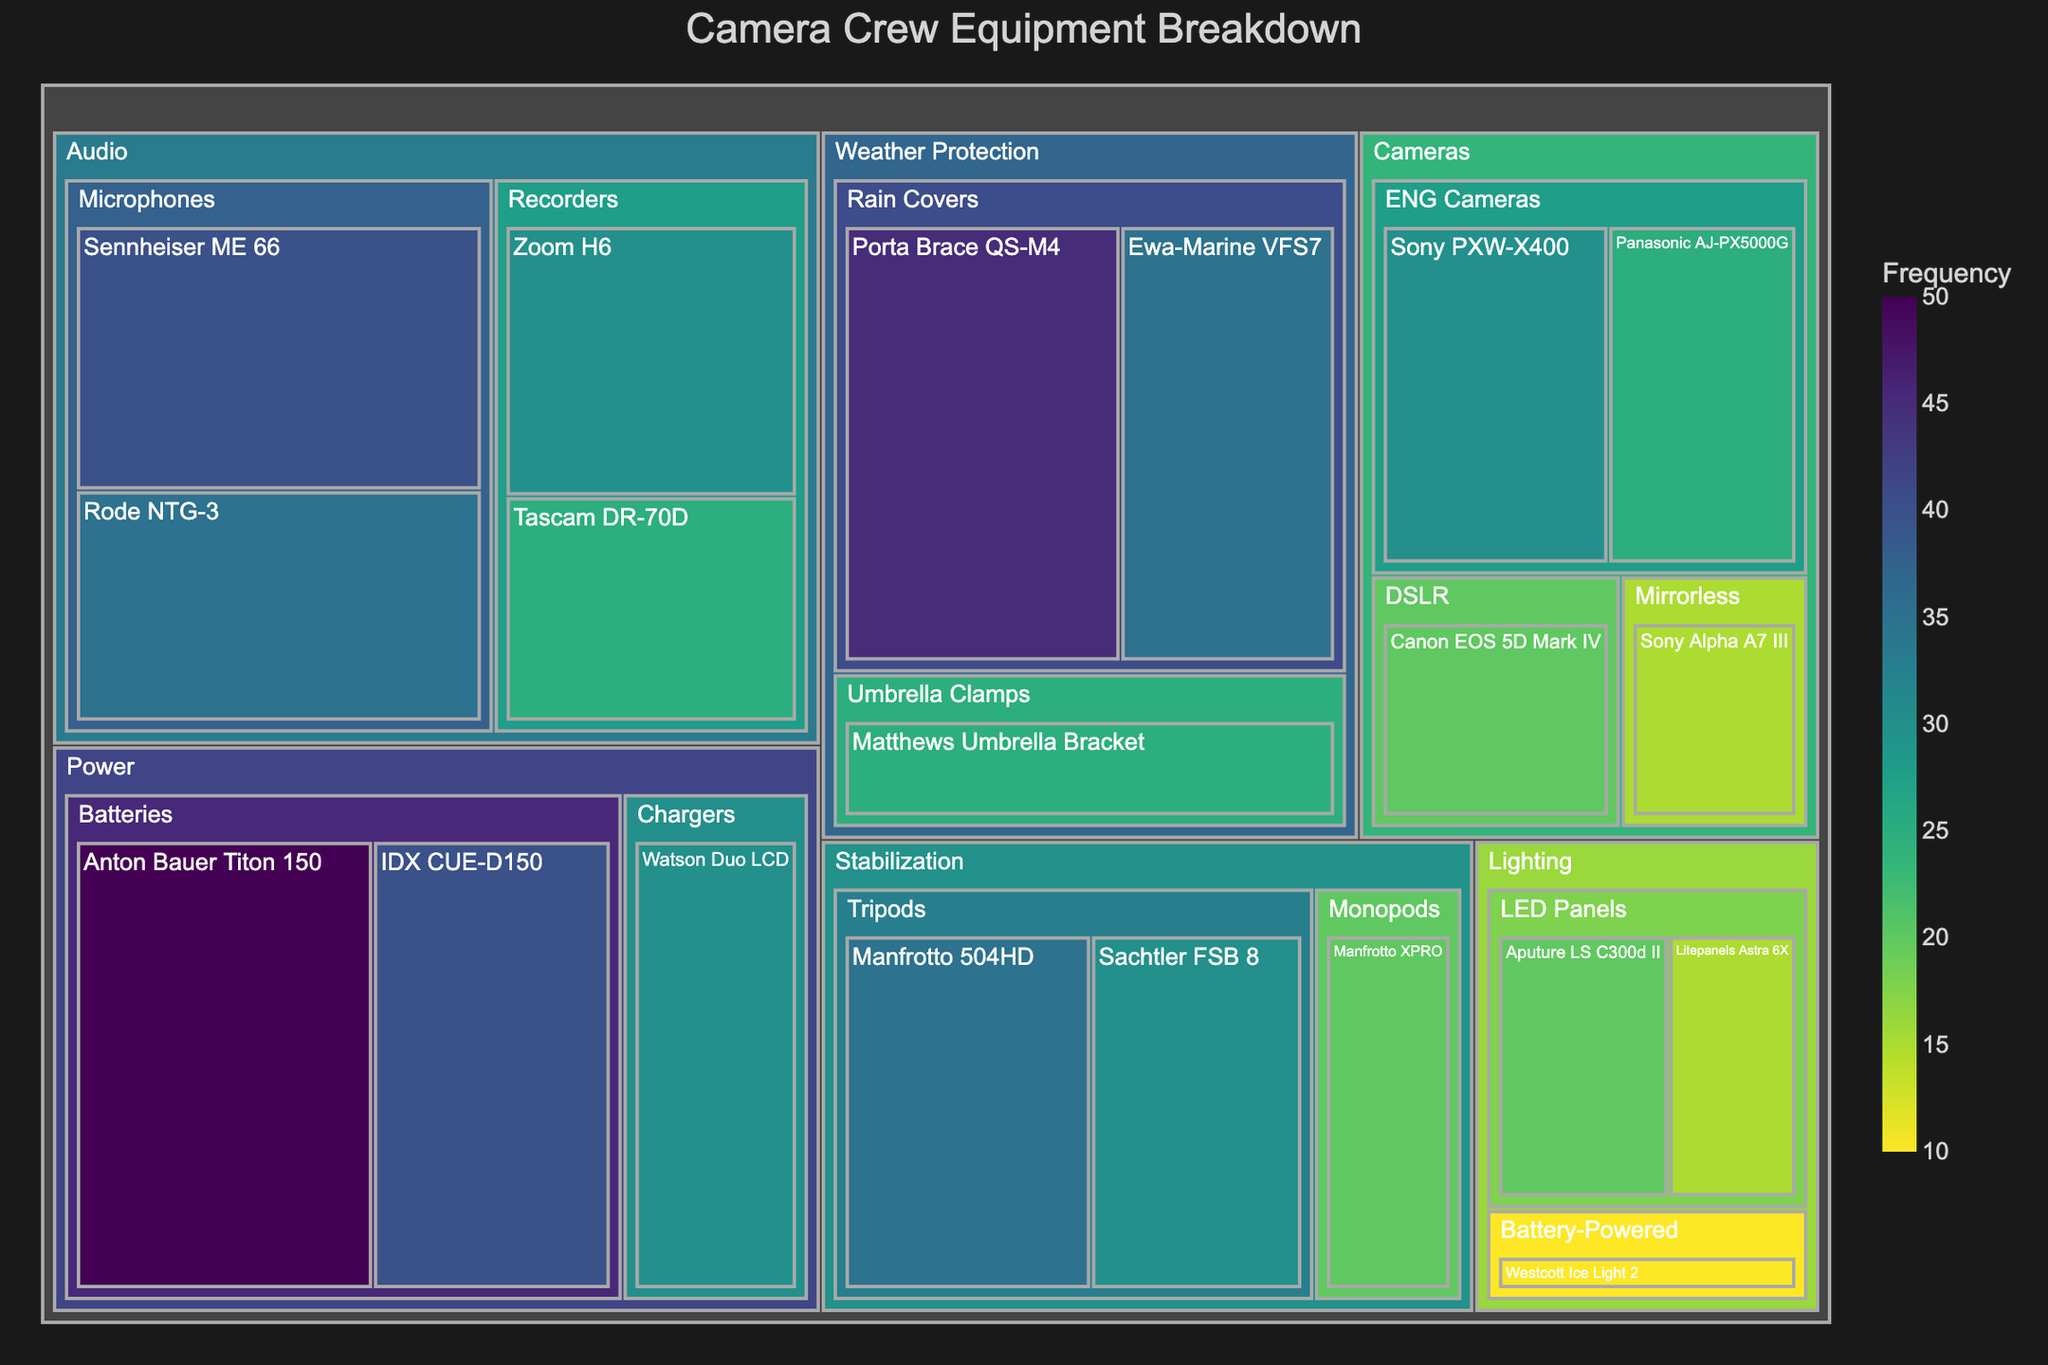Which equipment has the highest frequency in the 'Power' category? Find the 'Power' category and identify the equipment with the highest frequency. Anton Bauer Titon 150 has a frequency of 50, which is the highest in the 'Power' category.
Answer: Anton Bauer Titon 150 What is the total frequency of all equipment in the 'Stabilization' category? Identify all subcategories under 'Stabilization' and add their frequencies. Manfrotto 504HD (35) + Sachtler FSB 8 (30) + Manfrotto XPRO (20) = 35 + 30 + 20 = 85.
Answer: 85 Which subcategory has the lowest total frequency in the 'Lighting' category? Calculate the total frequency for each subcategory in 'Lighting' and compare them. LED Panels (20 + 15 = 35), Battery-Powered (10). Battery-Powered has the lowest total frequency of 10.
Answer: Battery-Powered How many pieces of equipment have a frequency above 30? Count all pieces of equipment with a frequency greater than 30. There are 7 pieces of equipment (Sony PXW-X400, Panasonic AJ-PX5000G, Sennheiser ME 66, Rode NTG-3, Porta Brace QS-M4, Anton Bauer Titon 150, IDX CUE-D150).
Answer: 7 Which categories contain equipment with a frequency of exactly 30? Identify all equipment with a frequency of 30 and note their categories. Sony PXW-X400 (Cameras), Zoom H6 (Audio), Sachtler FSB 8 (Stabilization), Watson Duo LCD (Power).
Answer: Cameras, Audio, Stabilization, Power What is the average frequency of all 'Microphones'? Identify all microphone frequencies and calculate their average. Sennheiser ME 66 (40) + Rode NTG-3 (35) = 40 + 35 = 75. The average is 75 / 2 = 37.5.
Answer: 37.5 Which category has the highest overall frequency? Sum the frequencies for each category and compare them. Cameras: 30 + 25 + 20 + 15 = 90, Audio: 40 + 35 + 30 + 25 = 130, Lighting: 20 + 15 + 10 = 45, Stabilization: 85, Weather Protection: 45 + 35 + 25 = 105, Power: 50 + 40 + 30 = 120. Audio has the highest overall frequency of 130.
Answer: Audio What is the combined frequency of 'Zoom H6' and 'Tascam DR-70D'? Add the frequencies of Zoom H6 (30) and Tascam DR-70D (25). 30 + 25 = 55.
Answer: 55 